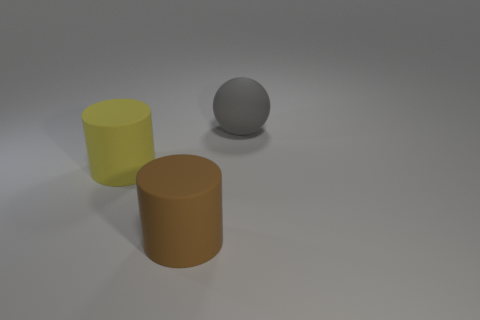Add 1 big green matte spheres. How many objects exist? 4 Subtract all spheres. How many objects are left? 2 Add 2 gray things. How many gray things exist? 3 Subtract 0 green blocks. How many objects are left? 3 Subtract all large spheres. Subtract all brown matte things. How many objects are left? 1 Add 3 brown objects. How many brown objects are left? 4 